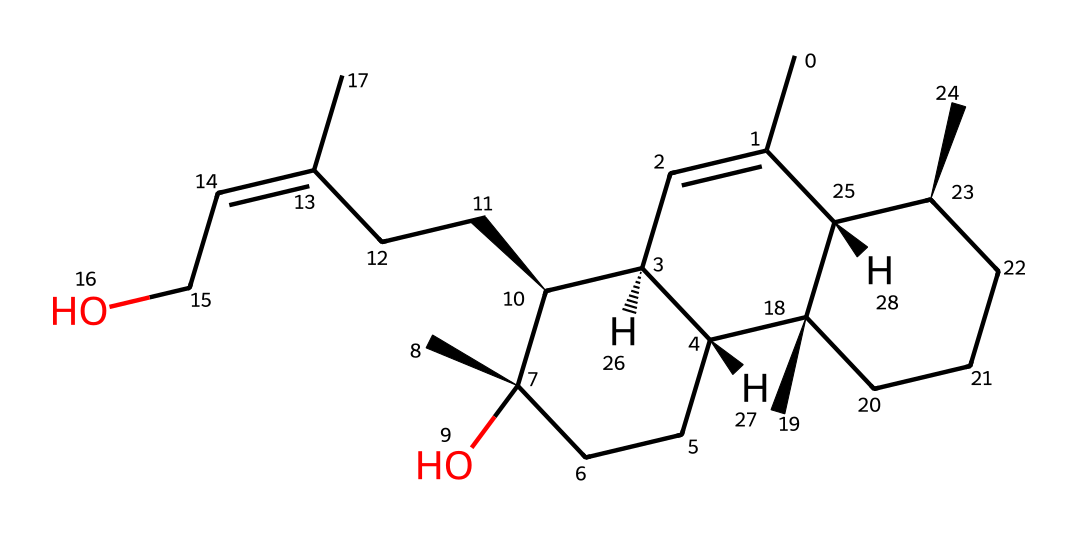What is the total number of carbon atoms in this chemical? By analyzing the SMILES representation, each 'C' represents a carbon atom. Counting all the carbon atoms, I find that there are 27 carbon atoms in the structure.
Answer: 27 How many ring structures are present in this chemical? The SMILES notation indicates the presence of ring structures as 'C1' and 'C2' starting points. Upon inspecting the structure, there are two distinct rings in the molecular makeup.
Answer: 2 What type of bonding predominates in this chemical? The SMILES notation shows mainly single bonds denoted by the absence of additional symbols like '=', and some double bonds represented by '='. However, the predominant type of bonding is single covalent bonding, which is typical for hydrocarbons.
Answer: single What functional groups are indicated by this chemical? The presence of 'O' in the SMILES notation suggests the inclusion of an alcohol functional group. Analyzing the structure, it can be inferred that there is a hydroxyl (-OH) group within the molecule, indicative of its potential sedative properties.
Answer: alcohol Is this chemical saturated or unsaturated? Examining the SMILES notation, the presence of double bonds (indicated by '/C(=C)' and '=' symbols) means that the chemical is not fully saturated. Therefore, this indicates it has double bonds, classifying it as unsaturated.
Answer: unsaturated What is the implied molecular formula based on this chemical's composition? Each element type can be counted from the SMILES representation; thus, after counting carbon (C), hydrogen (H), and oxygen (O) atoms, we deduce that the molecular formula would be C27H46O.
Answer: C27H46O Does this chemical belong to any specific subclass of hydrocarbons? Given that this chemical has hydroxyl groups and multiple carbon rings, it can be classified as a terpenoid or a sesquiterpene, which are subclasses of hydrocarbons known for natural sedative properties.
Answer: terpenoid 